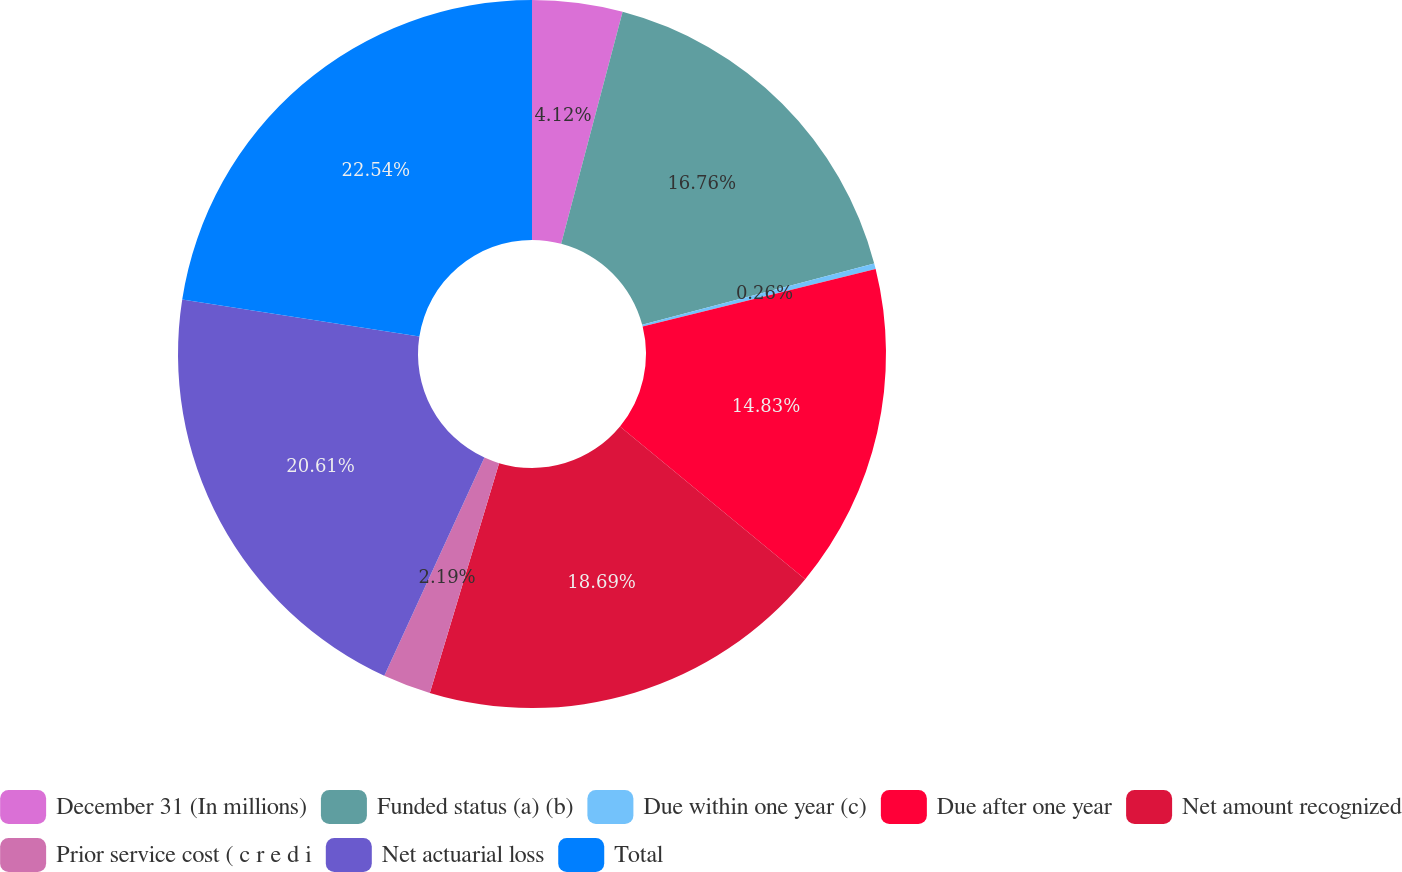Convert chart to OTSL. <chart><loc_0><loc_0><loc_500><loc_500><pie_chart><fcel>December 31 (In millions)<fcel>Funded status (a) (b)<fcel>Due within one year (c)<fcel>Due after one year<fcel>Net amount recognized<fcel>Prior service cost ( c r e d i<fcel>Net actuarial loss<fcel>Total<nl><fcel>4.12%<fcel>16.76%<fcel>0.26%<fcel>14.83%<fcel>18.69%<fcel>2.19%<fcel>20.61%<fcel>22.54%<nl></chart> 